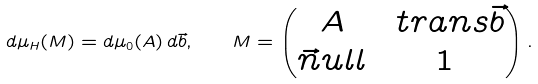Convert formula to latex. <formula><loc_0><loc_0><loc_500><loc_500>d \mu _ { H } ( M ) = d \mu _ { 0 } ( A ) \, d \vec { b } , \quad M = \begin{pmatrix} A & \ t r a n s \vec { b } \\ \vec { n } u l l & 1 \end{pmatrix} .</formula> 